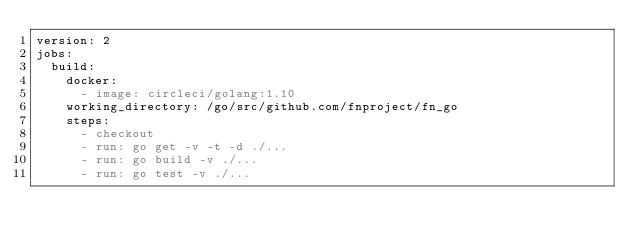Convert code to text. <code><loc_0><loc_0><loc_500><loc_500><_YAML_>version: 2
jobs:
  build:
    docker:
      - image: circleci/golang:1.10
    working_directory: /go/src/github.com/fnproject/fn_go
    steps:
      - checkout
      - run: go get -v -t -d ./...
      - run: go build -v ./...
      - run: go test -v ./...</code> 